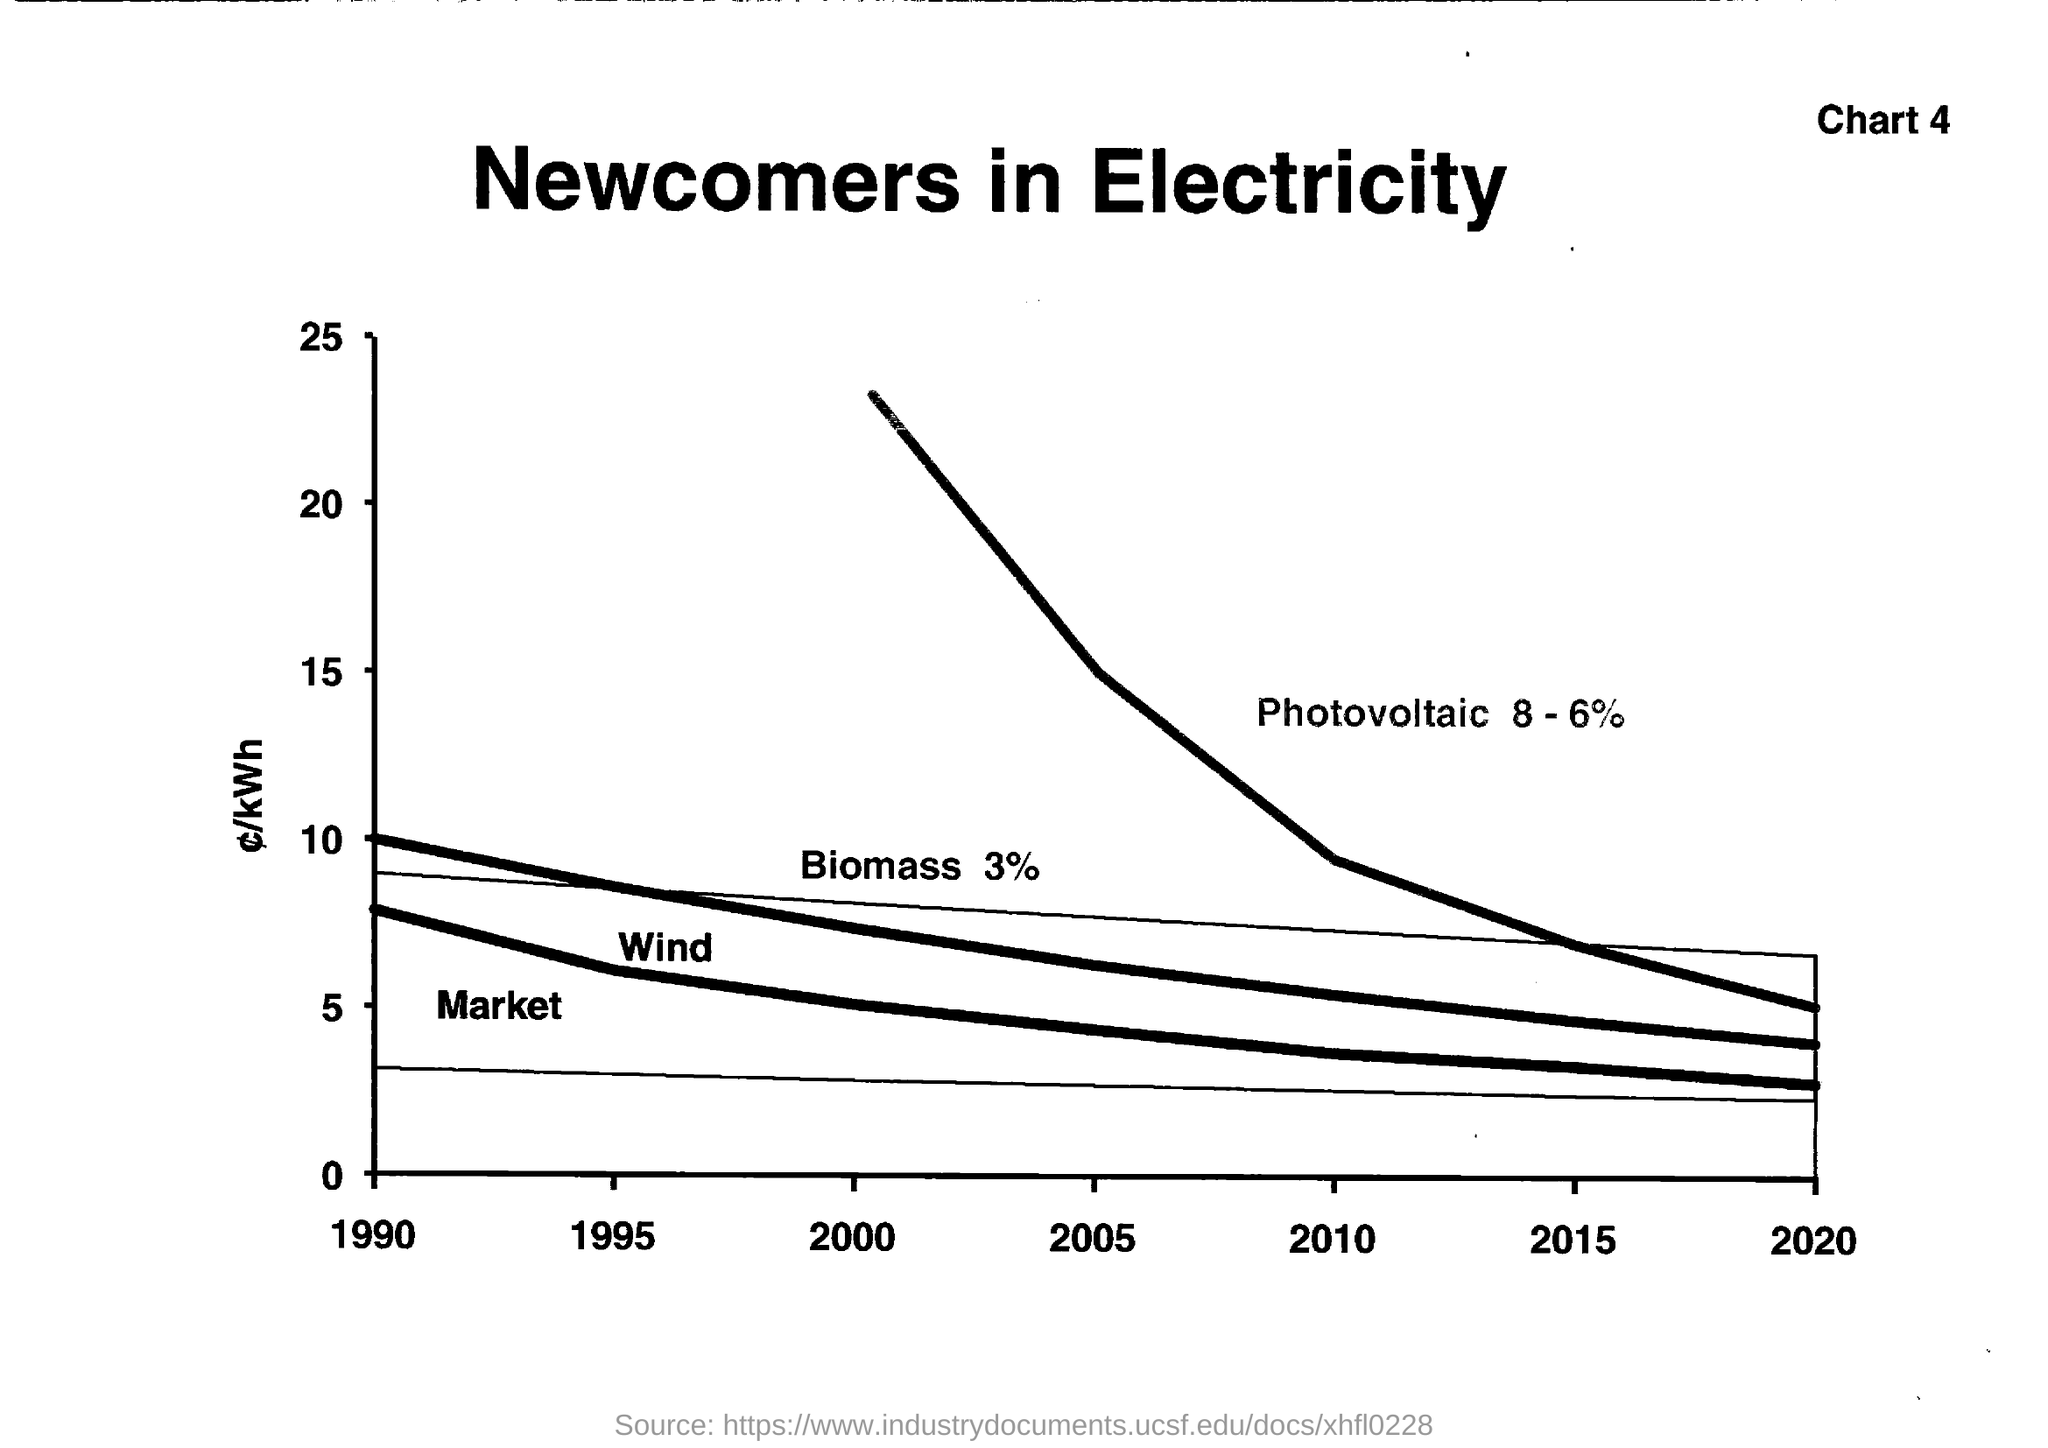Identify some key points in this picture. The chart number is 4. The photovoltaic percentage is approximately 8 to 6%, which means that solar panels generate electricity that ranges from 8% to 6% of their maximum possible output. The title of the document is 'Newcomers in Electricity.' The biomass percentage is 3%. 